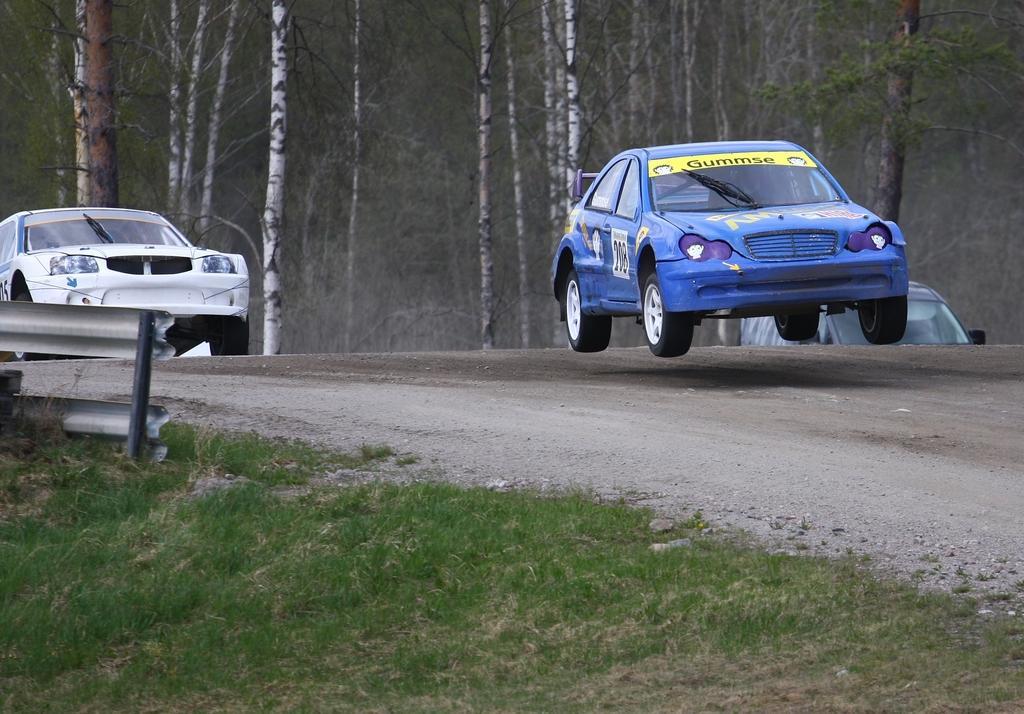Could you give a brief overview of what you see in this image? In this image I can see grass and a road in the front. On the road I can see few cars and in the background I can see number of trees. 